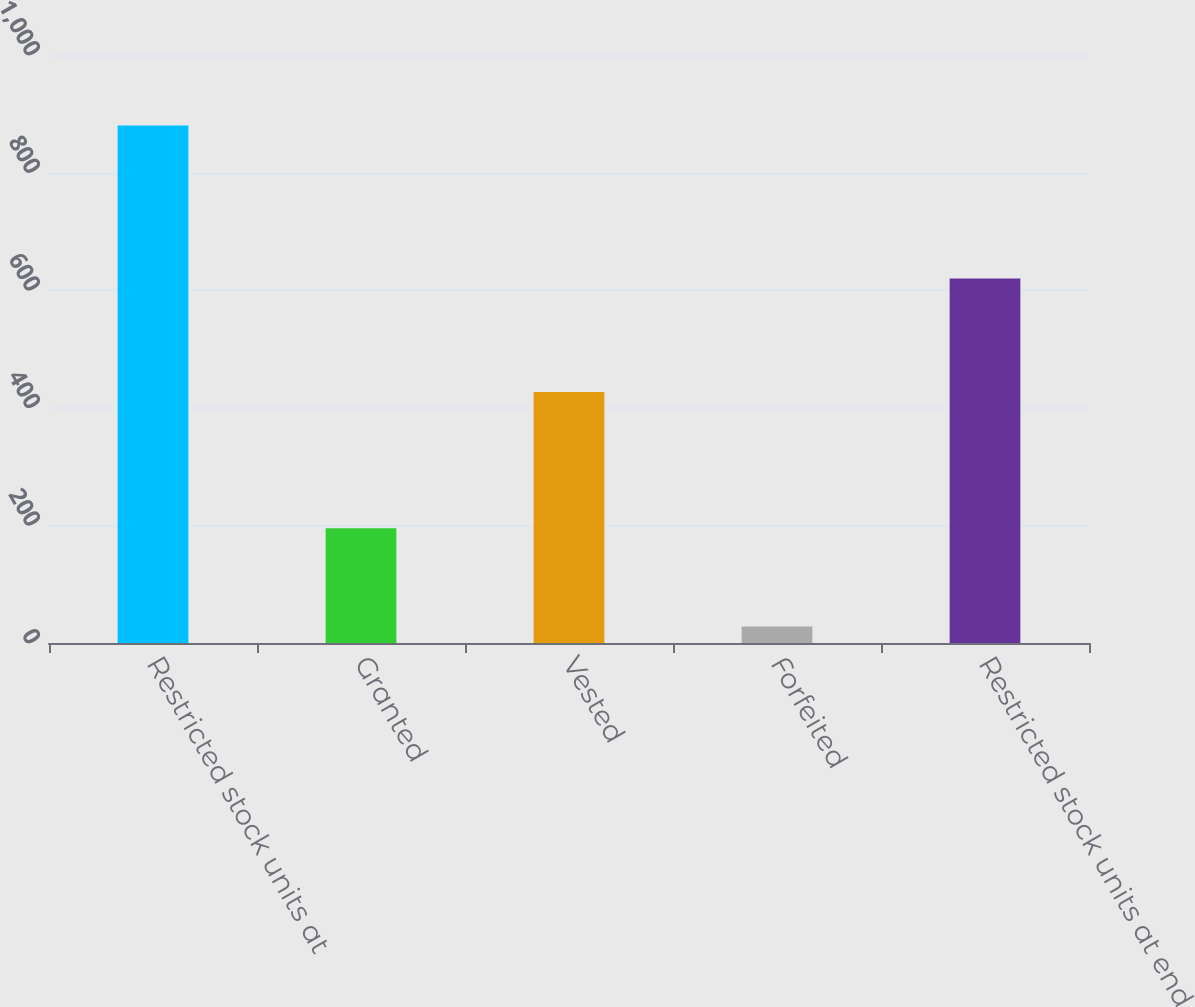<chart> <loc_0><loc_0><loc_500><loc_500><bar_chart><fcel>Restricted stock units at<fcel>Granted<fcel>Vested<fcel>Forfeited<fcel>Restricted stock units at end<nl><fcel>880<fcel>195<fcel>427<fcel>28<fcel>620<nl></chart> 